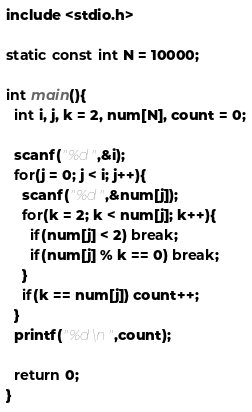<code> <loc_0><loc_0><loc_500><loc_500><_C_>include <stdio.h>

static const int N = 10000;

int main(){
  int i, j, k = 2, num[N], count = 0;

  scanf("%d",&i);
  for(j = 0; j < i; j++){
    scanf("%d",&num[j]);
    for(k = 2; k < num[j]; k++){
      if(num[j] < 2) break;
      if(num[j] % k == 0) break;
    }
    if(k == num[j]) count++;
  }
  printf("%d\n",count);
  
  return 0;
}</code> 